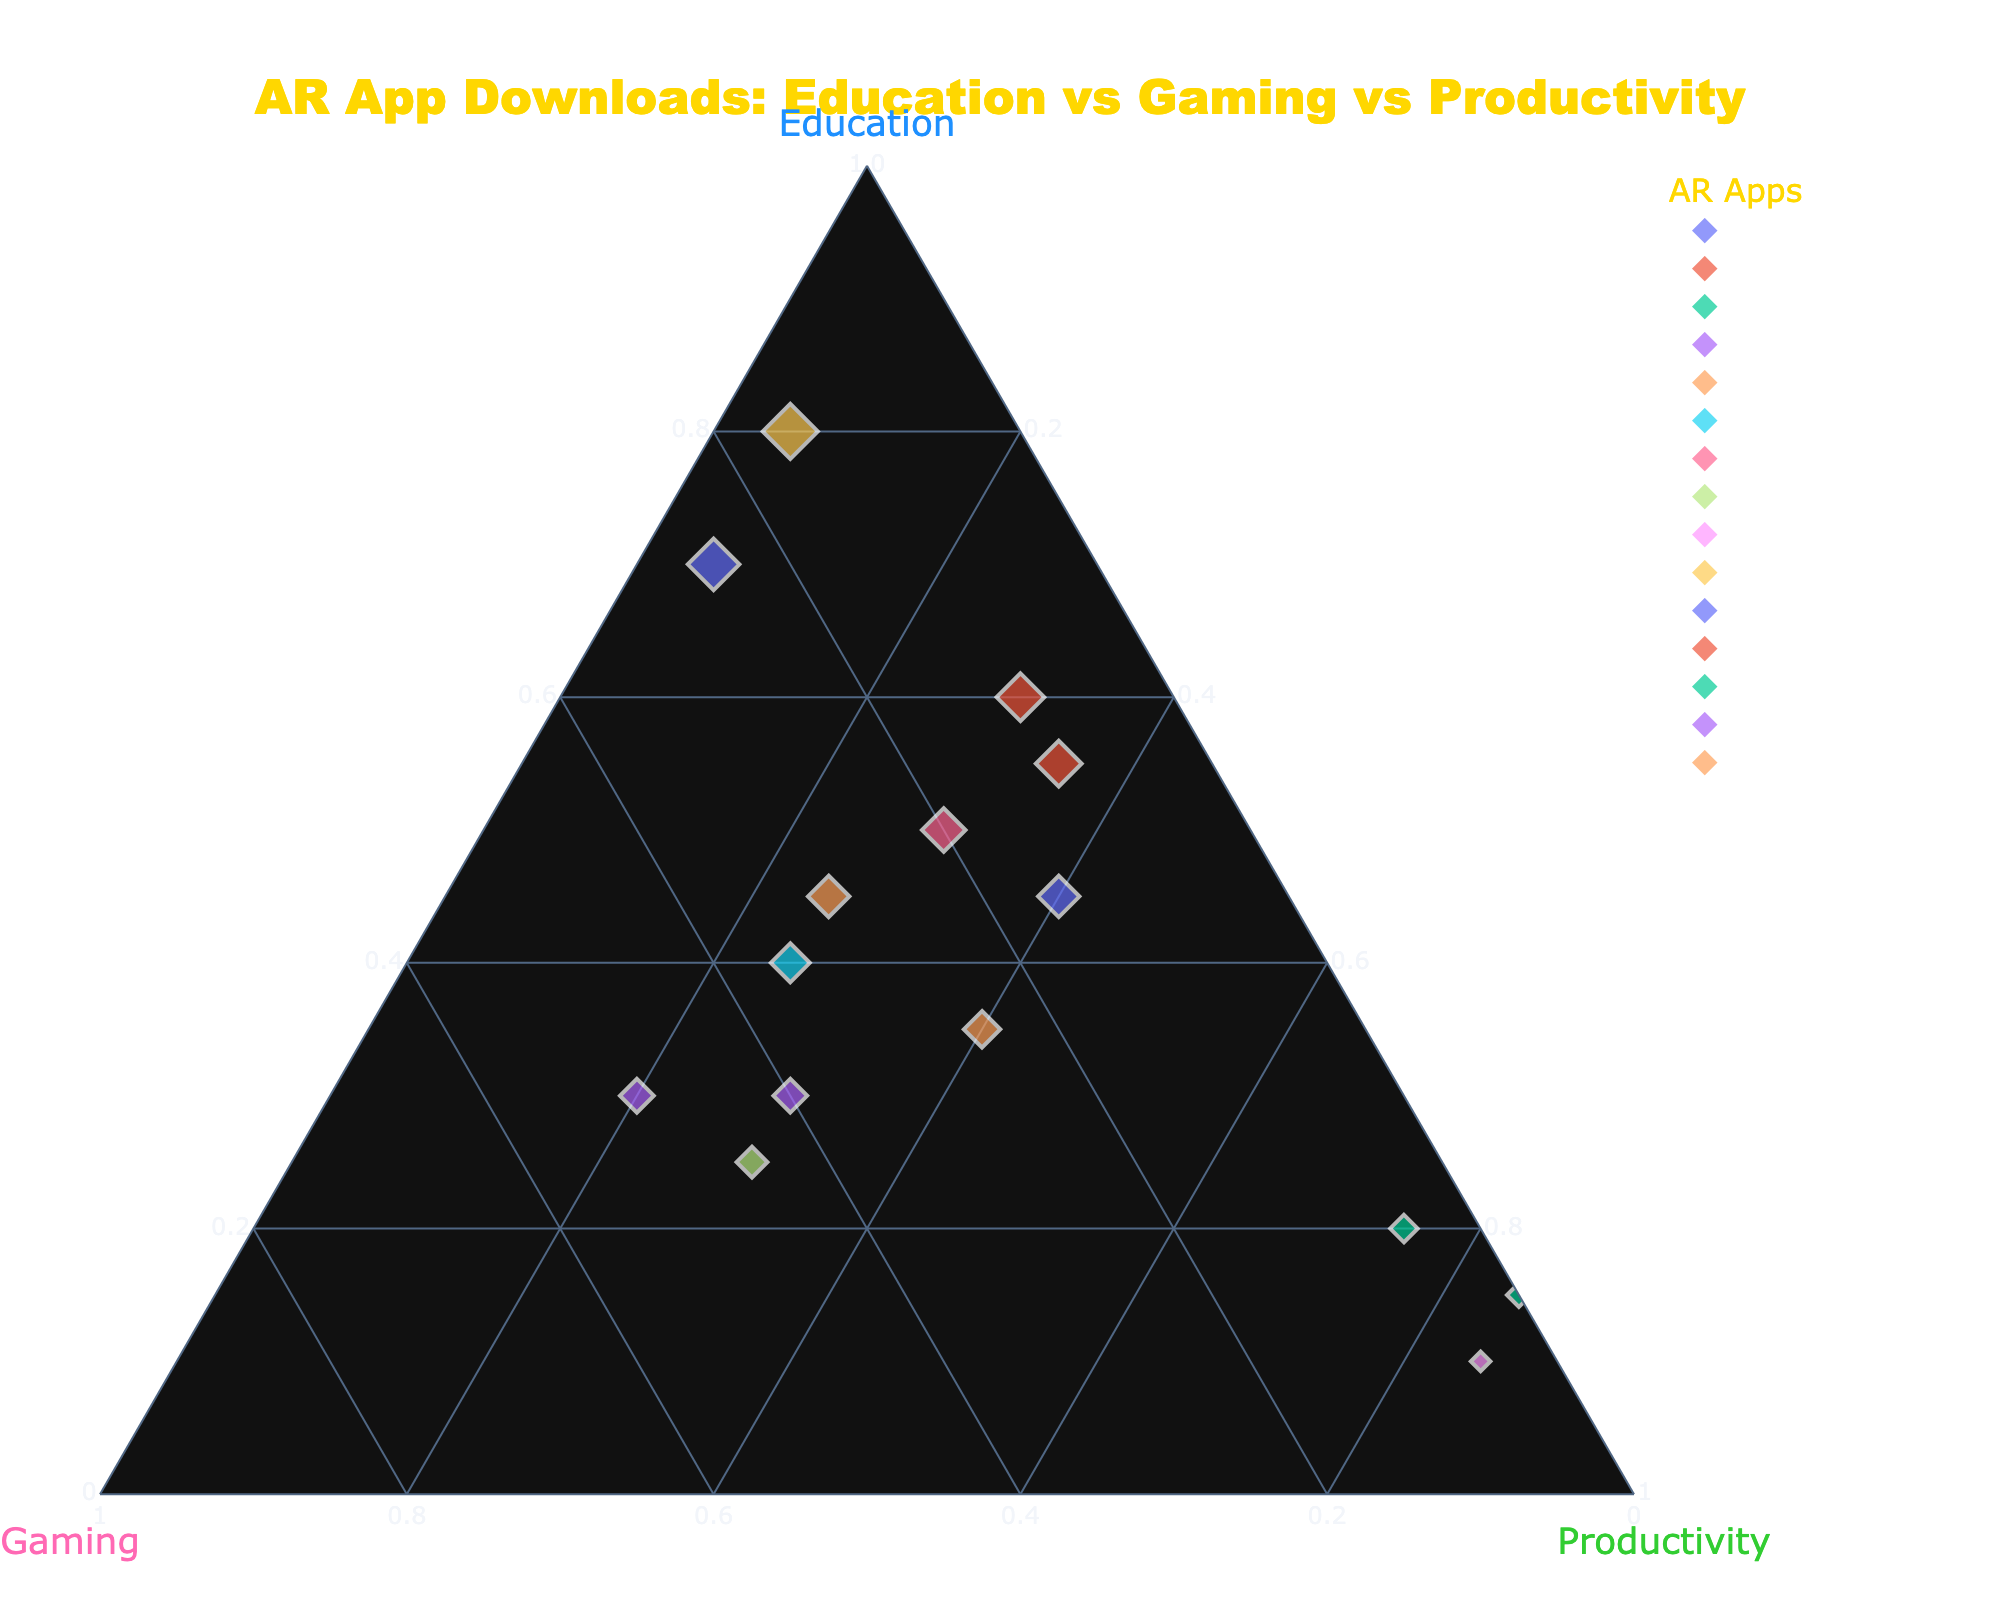What's the title of the plot? The title is displayed at the top center of the figure, indicated by a larger font size and often distinctively colored. In this plot, the title is "AR App Downloads: Education vs Gaming vs Productivity."
Answer: AR App Downloads: Education vs Gaming vs Productivity How many axes are present in the ternary plot? Ternary plots have three axes, each representing one component of the composition. This is evident in the plot where there are three labeled axes titled "Education," "Gaming," and "Productivity."
Answer: Three Which AR app has the highest percentage of education-related downloads? We need to look for the highest value along the "Education" axis. Mondly AR has the highest education percentage, at 80%.
Answer: Mondly AR Which app shows an equal percentage of downloads for gaming and productivity? Observing the locations on the plot where the values for the "Gaming" and "Productivity" axes are equal, we find that ARCore Elements has both gaming and productivity percentages at 30%.
Answer: ARCore Elements What is the sum of the education and gaming percentages for ARLearn? To find the sum, we add the education percentage (45%) and gaming percentage (15%) for ARLearn. This results in 45 + 15 = 60%.
Answer: 60% Which category has the least percentage of downloads for the app "DAQRI Worksense"? Reviewing the "Education," "Gaming," and "Productivity" percentages for DAQRI Worksense, we find the respective values are 20%, 5%, and 75%. The smallest value is in gaming at 5%.
Answer: Gaming Compare the education percentages of Quiver and JigSpace. Which one has more? Quiver has an education percentage of 70%, while JigSpace has 55%. Therefore, Quiver has a higher education percentage than JigSpace.
Answer: Quiver Which app lies closest to the "Gaming" axis maximum? The app closest to the maximum of the "Gaming" axis would have the highest value for gaming. Zappar is nearest, with a gaming percentage of 50%.
Answer: Zappar What is the median value of the education percentages across all AR apps? To determine the median, we first list all the education percentages in ascending order: 10, 15, 20, 25, 30, 30, 35, 40, 45, 45, 50, 55, 60, 70, 80. The middle value (median) is the 8th in this 15-value list: 40.
Answer: 40 How do the "AR Measure" and "AR Ruler" apps compare in terms of productivity downloads? For "AR Measure," the productivity percentage is 85%. For "AR Ruler," it is also 85%. Both apps have equal productivity download percentages.
Answer: Equal 